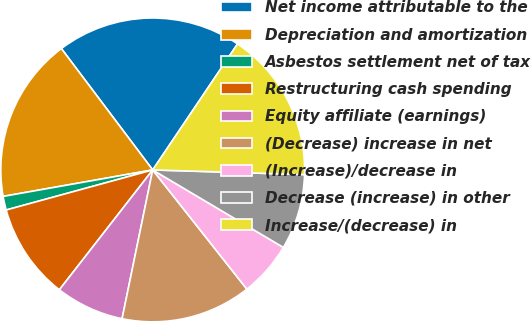Convert chart. <chart><loc_0><loc_0><loc_500><loc_500><pie_chart><fcel>Net income attributable to the<fcel>Depreciation and amortization<fcel>Asbestos settlement net of tax<fcel>Restructuring cash spending<fcel>Equity affiliate (earnings)<fcel>(Decrease) increase in net<fcel>(Increase)/decrease in<fcel>Decrease (increase) in other<fcel>Increase/(decrease) in<nl><fcel>19.7%<fcel>17.52%<fcel>1.46%<fcel>10.22%<fcel>7.3%<fcel>13.87%<fcel>5.84%<fcel>8.03%<fcel>16.06%<nl></chart> 